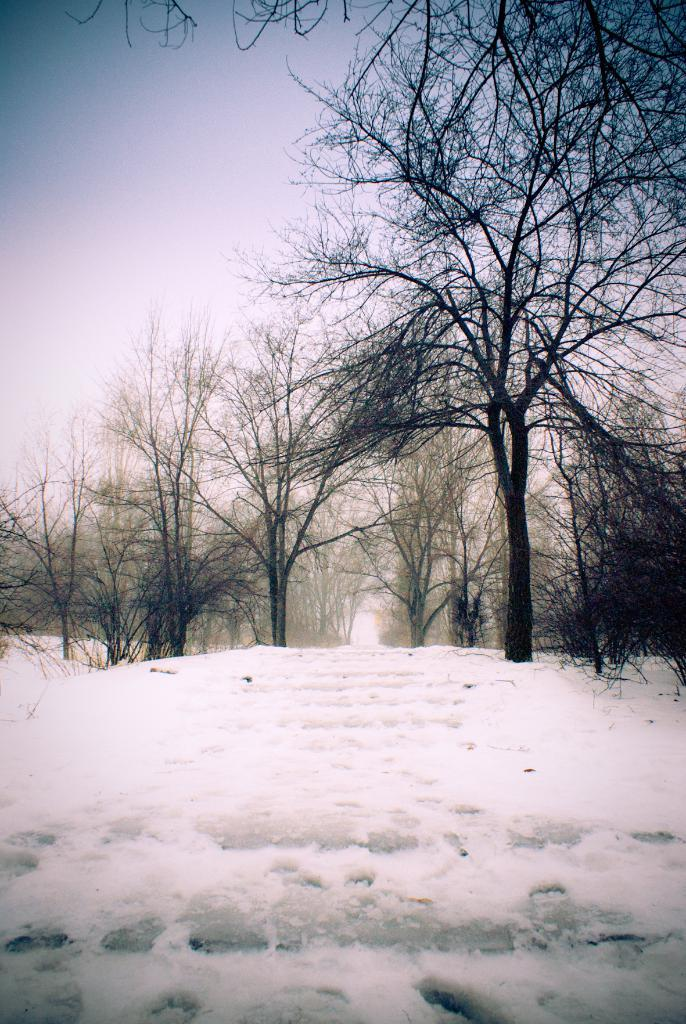What type of weather is depicted in the image? There is snow in the image, which suggests cold weather. What type of vegetation can be seen in the image? There are trees in the image. What is visible in the background of the image? The sky is visible in the background of the image. Can you tell me how many kittens are playing in the snow in the image? There are no kittens present in the image; it only features snow and trees. 